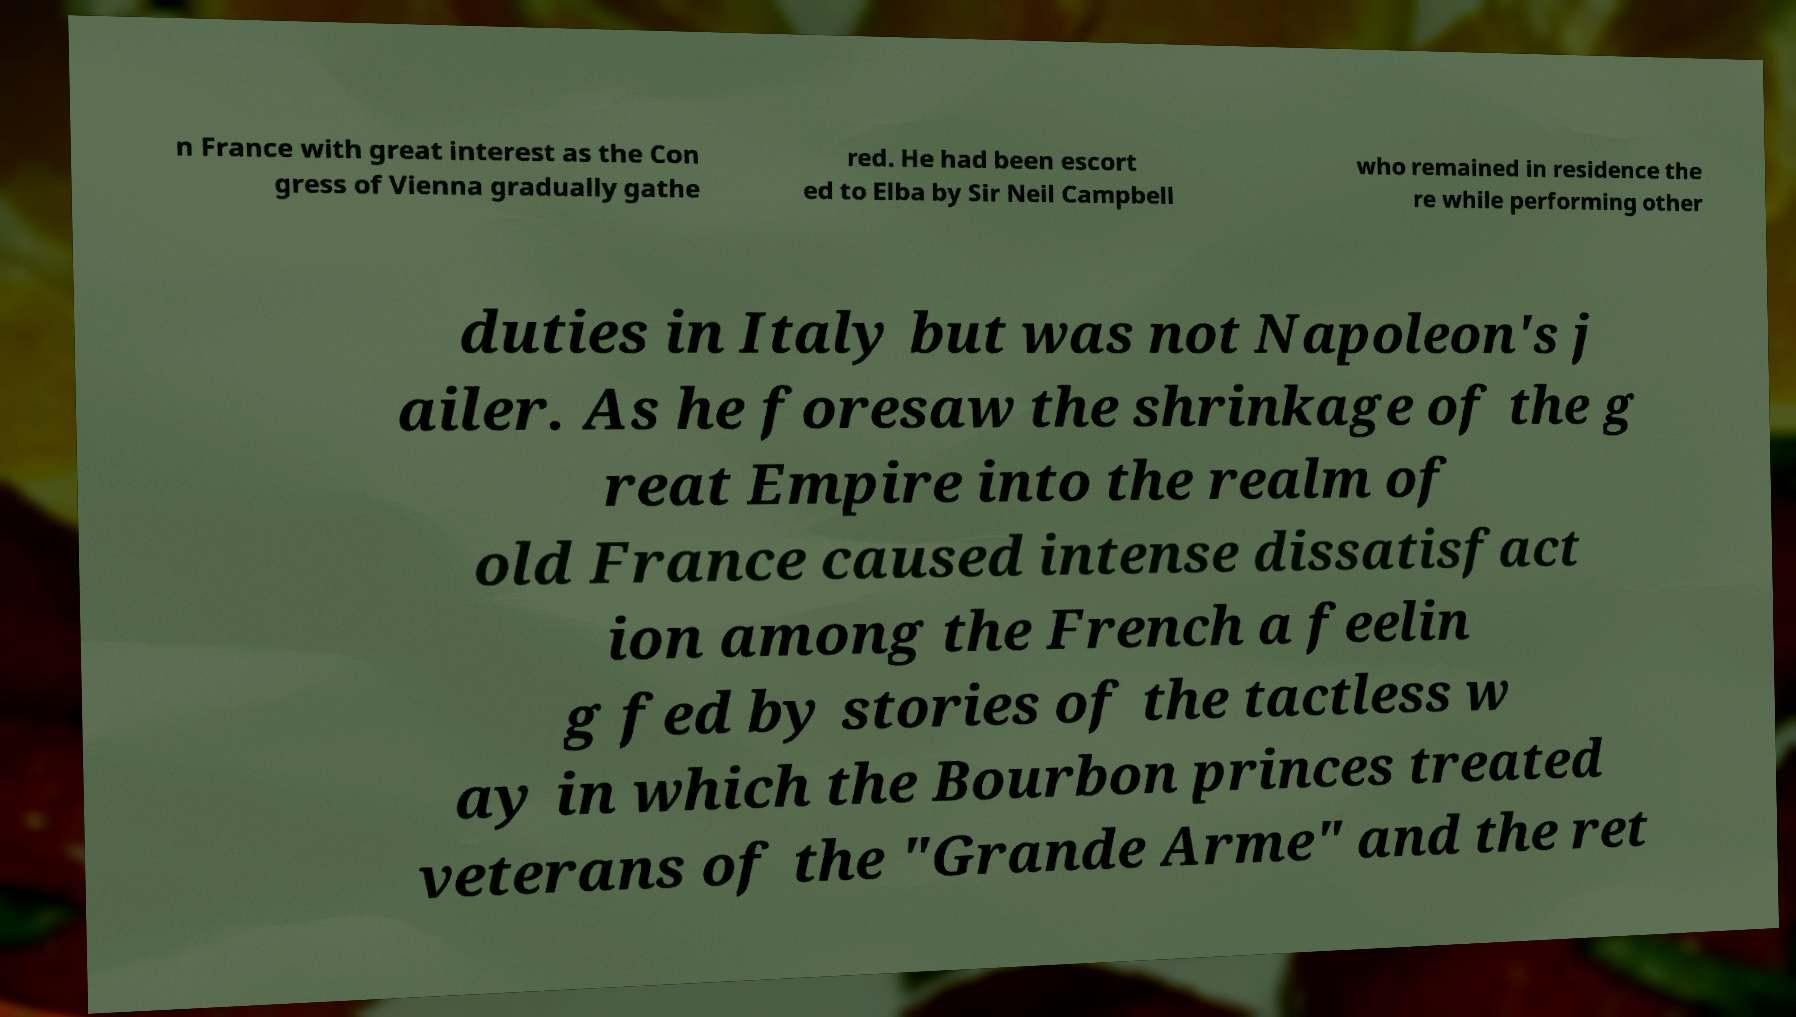Could you assist in decoding the text presented in this image and type it out clearly? n France with great interest as the Con gress of Vienna gradually gathe red. He had been escort ed to Elba by Sir Neil Campbell who remained in residence the re while performing other duties in Italy but was not Napoleon's j ailer. As he foresaw the shrinkage of the g reat Empire into the realm of old France caused intense dissatisfact ion among the French a feelin g fed by stories of the tactless w ay in which the Bourbon princes treated veterans of the "Grande Arme" and the ret 